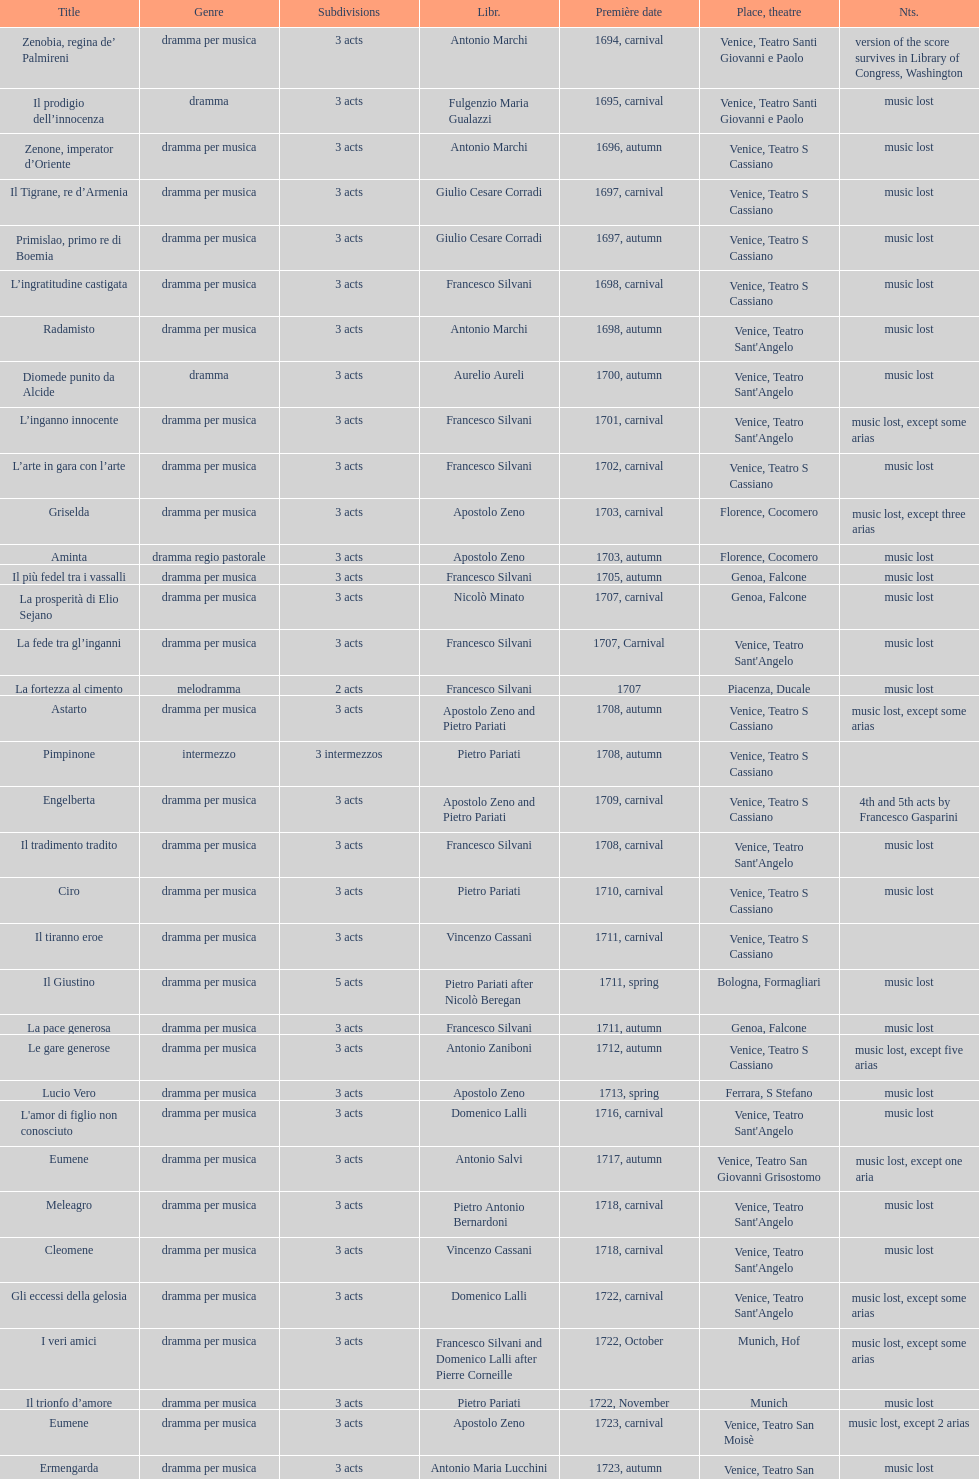Which title premiered directly after candalide? Artamene. 